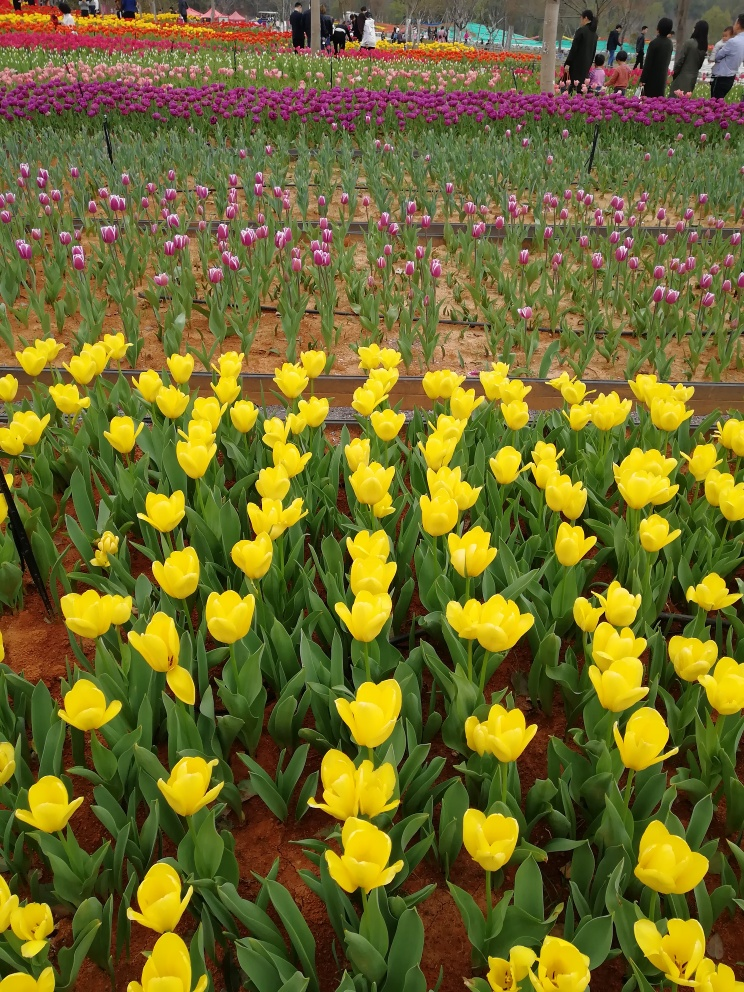Could you explain how the arrangement of these tulips affects the visual impact of the image? The strategic placement of tulips in this image creates a striking visual impact through the use of color blocking and alternating rows of yellow and purple. This arrangement highlights the contrast between the colors, drawing the viewer's eye across the image and providing a sense of rhythm and movement. The recurring patterns not only enhance the aesthetic appeal but also demonstrate skilled garden design, encouraging an immersive viewing experience. 